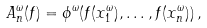<formula> <loc_0><loc_0><loc_500><loc_500>A _ { n } ^ { \omega } ( f ) = \phi ^ { \omega } ( f ( x _ { 1 } ^ { \omega } ) , \dots , f ( x _ { n } ^ { \omega } ) ) \, ,</formula> 